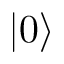Convert formula to latex. <formula><loc_0><loc_0><loc_500><loc_500>| 0 \rangle</formula> 